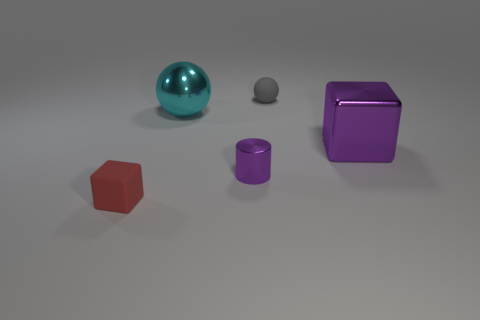Add 3 large yellow metallic balls. How many objects exist? 8 Subtract all cylinders. How many objects are left? 4 Subtract 0 green balls. How many objects are left? 5 Subtract all shiny balls. Subtract all tiny metallic objects. How many objects are left? 3 Add 5 large shiny spheres. How many large shiny spheres are left? 6 Add 3 small gray rubber balls. How many small gray rubber balls exist? 4 